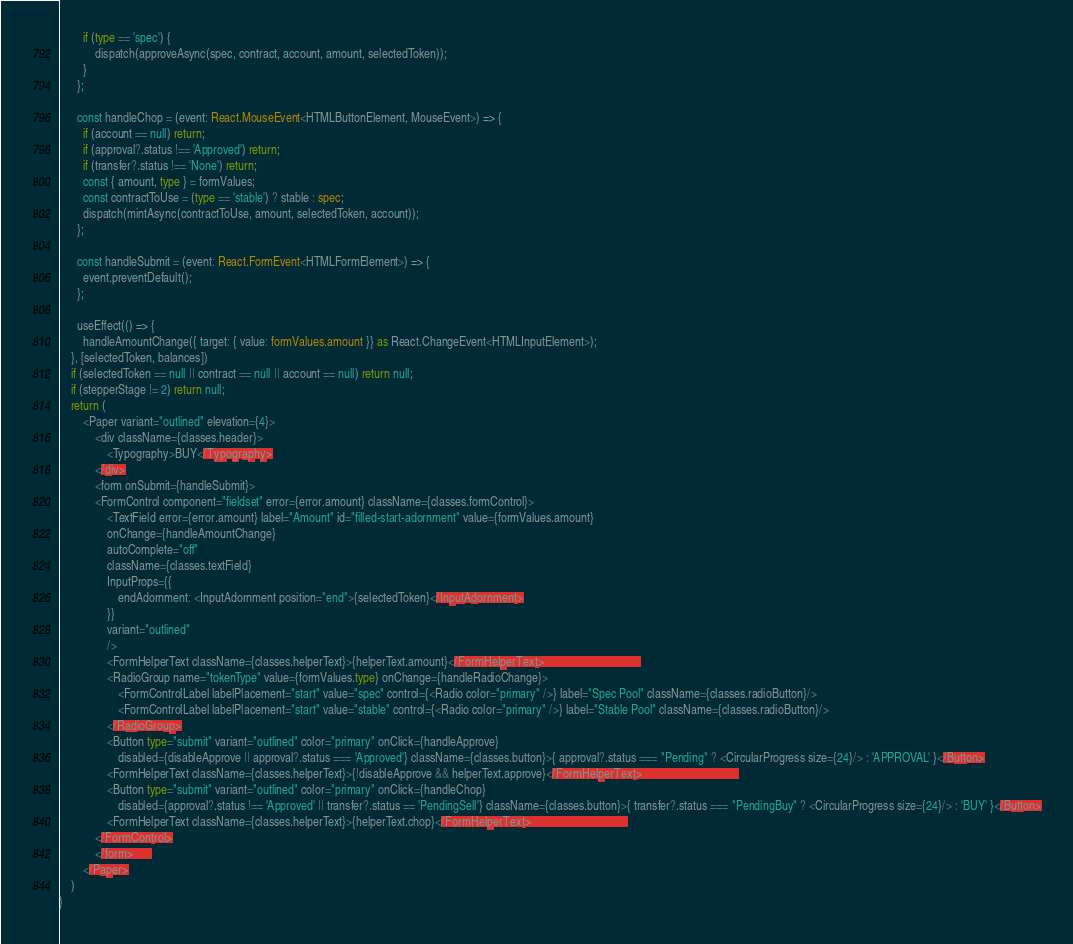<code> <loc_0><loc_0><loc_500><loc_500><_TypeScript_>        if (type == 'spec') {
            dispatch(approveAsync(spec, contract, account, amount, selectedToken));
        }
      };

      const handleChop = (event: React.MouseEvent<HTMLButtonElement, MouseEvent>) => {
        if (account == null) return;
        if (approval?.status !== 'Approved') return;
        if (transfer?.status !== 'None') return;
        const { amount, type } = formValues;
        const contractToUse = (type == 'stable') ? stable : spec;
        dispatch(mintAsync(contractToUse, amount, selectedToken, account));
      };

      const handleSubmit = (event: React.FormEvent<HTMLFormElement>) => {
        event.preventDefault();
      };

      useEffect(() => {
        handleAmountChange({ target: { value: formValues.amount }} as React.ChangeEvent<HTMLInputElement>);
    }, [selectedToken, balances])
    if (selectedToken == null || contract == null || account == null) return null;
    if (stepperStage != 2) return null; 
    return (
        <Paper variant="outlined" elevation={4}>
            <div className={classes.header}>
                <Typography>BUY</Typography>
            </div>
            <form onSubmit={handleSubmit}>
            <FormControl component="fieldset" error={error.amount} className={classes.formControl}>
                <TextField error={error.amount} label="Amount" id="filled-start-adornment" value={formValues.amount}
                onChange={handleAmountChange}
                autoComplete="off"
                className={classes.textField}
                InputProps={{
                    endAdornment: <InputAdornment position="end">{selectedToken}</InputAdornment>
                }}
                variant="outlined"
                />
                <FormHelperText className={classes.helperText}>{helperText.amount}</FormHelperText>                                
                <RadioGroup name="tokenType" value={formValues.type} onChange={handleRadioChange}>
                    <FormControlLabel labelPlacement="start" value="spec" control={<Radio color="primary" />} label="Spec Pool" className={classes.radioButton}/>
                    <FormControlLabel labelPlacement="start" value="stable" control={<Radio color="primary" />} label="Stable Pool" className={classes.radioButton}/>
                </RadioGroup>
                <Button type="submit" variant="outlined" color="primary" onClick={handleApprove}
                    disabled={disableApprove || approval?.status === 'Approved'} className={classes.button}>{ approval?.status === "Pending" ? <CircularProgress size={24}/> : 'APPROVAL' }</Button>
                <FormHelperText className={classes.helperText}>{!disableApprove && helperText.approve}</FormHelperText>                                
                <Button type="submit" variant="outlined" color="primary" onClick={handleChop}
                    disabled={approval?.status !== 'Approved' || transfer?.status == 'PendingSell'} className={classes.button}>{ transfer?.status === "PendingBuy" ? <CircularProgress size={24}/> : 'BUY' }</Button>
                <FormHelperText className={classes.helperText}>{helperText.chop}</FormHelperText>                                
            </FormControl>
            </form>      
        </Paper>
    )
}</code> 